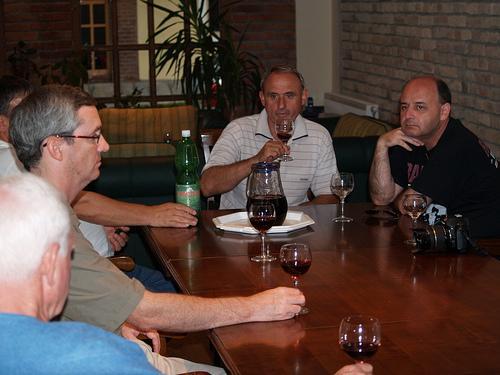What can happen if too much of this liquid is ingested? drunk 